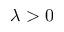<formula> <loc_0><loc_0><loc_500><loc_500>\lambda > 0</formula> 